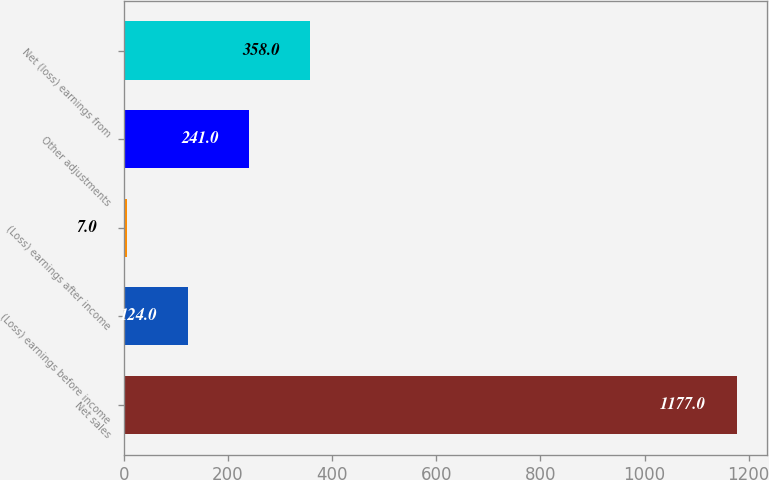Convert chart. <chart><loc_0><loc_0><loc_500><loc_500><bar_chart><fcel>Net sales<fcel>(Loss) earnings before income<fcel>(Loss) earnings after income<fcel>Other adjustments<fcel>Net (loss) earnings from<nl><fcel>1177<fcel>124<fcel>7<fcel>241<fcel>358<nl></chart> 